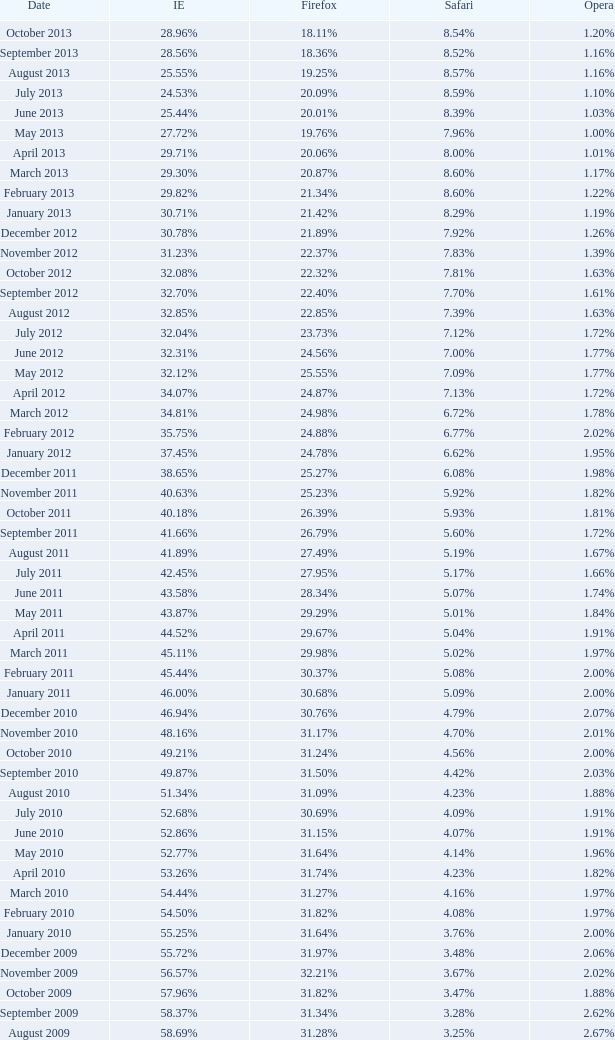What percentage of browsers were using Internet Explorer during the period in which 27.85% were using Firefox? 64.43%. 